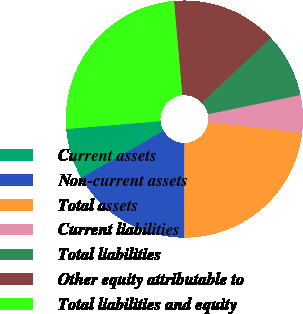<chart> <loc_0><loc_0><loc_500><loc_500><pie_chart><fcel>Current assets<fcel>Non-current assets<fcel>Total assets<fcel>Current liabilities<fcel>Total liabilities<fcel>Other equity attributable to<fcel>Total liabilities and equity<nl><fcel>6.94%<fcel>16.7%<fcel>23.14%<fcel>5.14%<fcel>8.76%<fcel>14.38%<fcel>24.94%<nl></chart> 